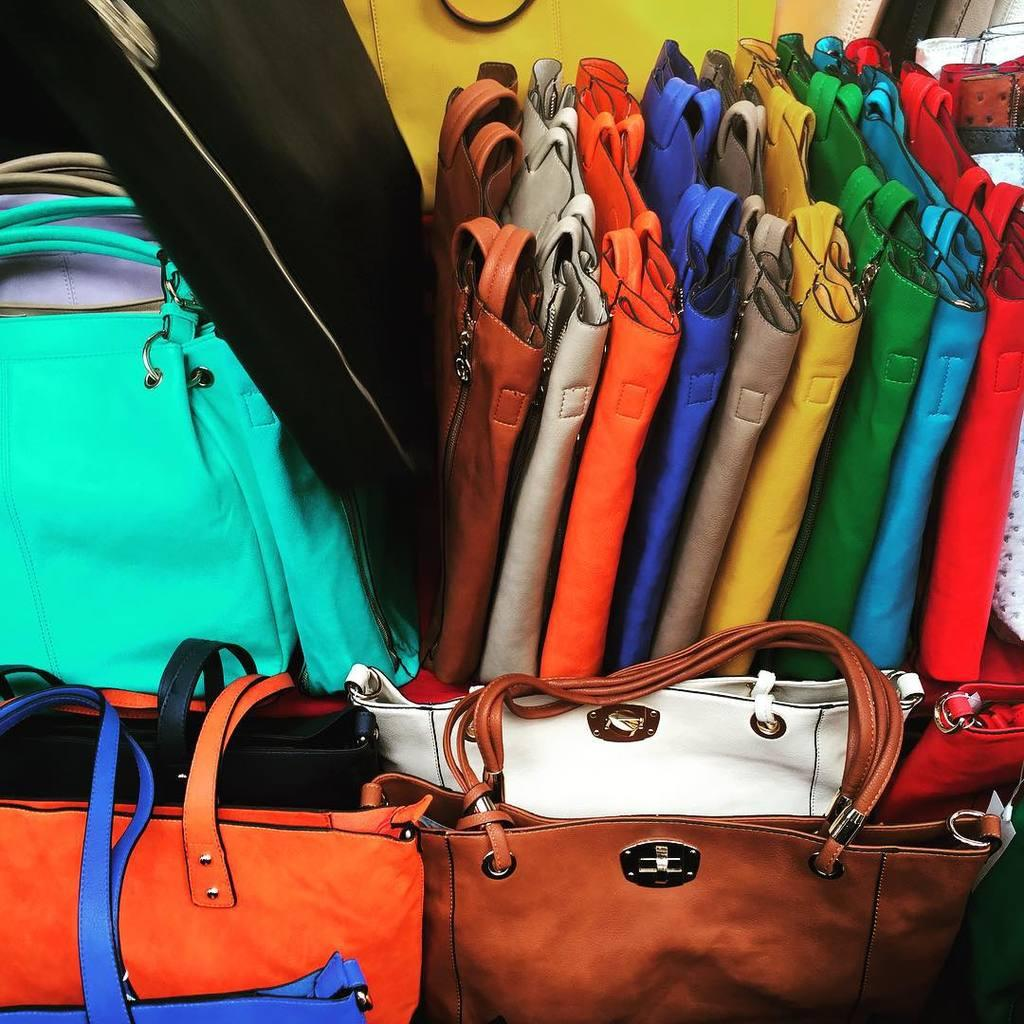What type of items are present in the image? There are handbags in the image. Can you describe the handbags in terms of their colors? The handbags are of different colors. How are the handbags arranged in the image? The handbags are arranged in an order. What distinguishes the handbags from one another? The handbags have different shapes and sizes. What rule is being enforced by the handbags in the image? There is no rule being enforced by the handbags in the image; they are simply objects arranged in a certain way. Can you identify any nuts present in the image? There are no nuts present in the image; it features handbags of different colors, shapes, and sizes. 